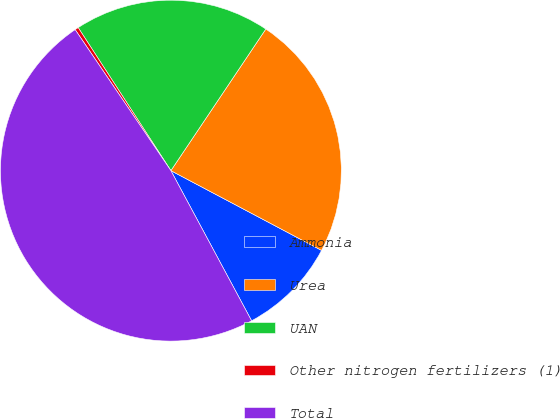<chart> <loc_0><loc_0><loc_500><loc_500><pie_chart><fcel>Ammonia<fcel>Urea<fcel>UAN<fcel>Other nitrogen fertilizers (1)<fcel>Total<nl><fcel>9.4%<fcel>23.35%<fcel>18.55%<fcel>0.34%<fcel>48.36%<nl></chart> 